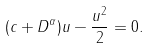Convert formula to latex. <formula><loc_0><loc_0><loc_500><loc_500>( c + D ^ { \alpha } ) u - \frac { u ^ { 2 } } { 2 } = 0 .</formula> 